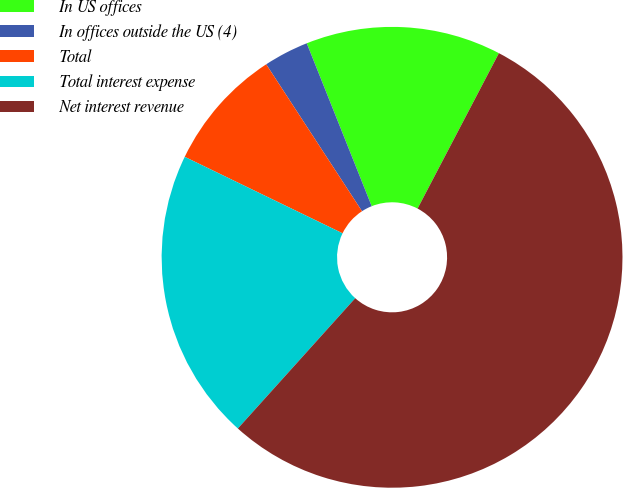Convert chart. <chart><loc_0><loc_0><loc_500><loc_500><pie_chart><fcel>In US offices<fcel>In offices outside the US (4)<fcel>Total<fcel>Total interest expense<fcel>Net interest revenue<nl><fcel>13.71%<fcel>3.16%<fcel>8.62%<fcel>20.51%<fcel>53.99%<nl></chart> 